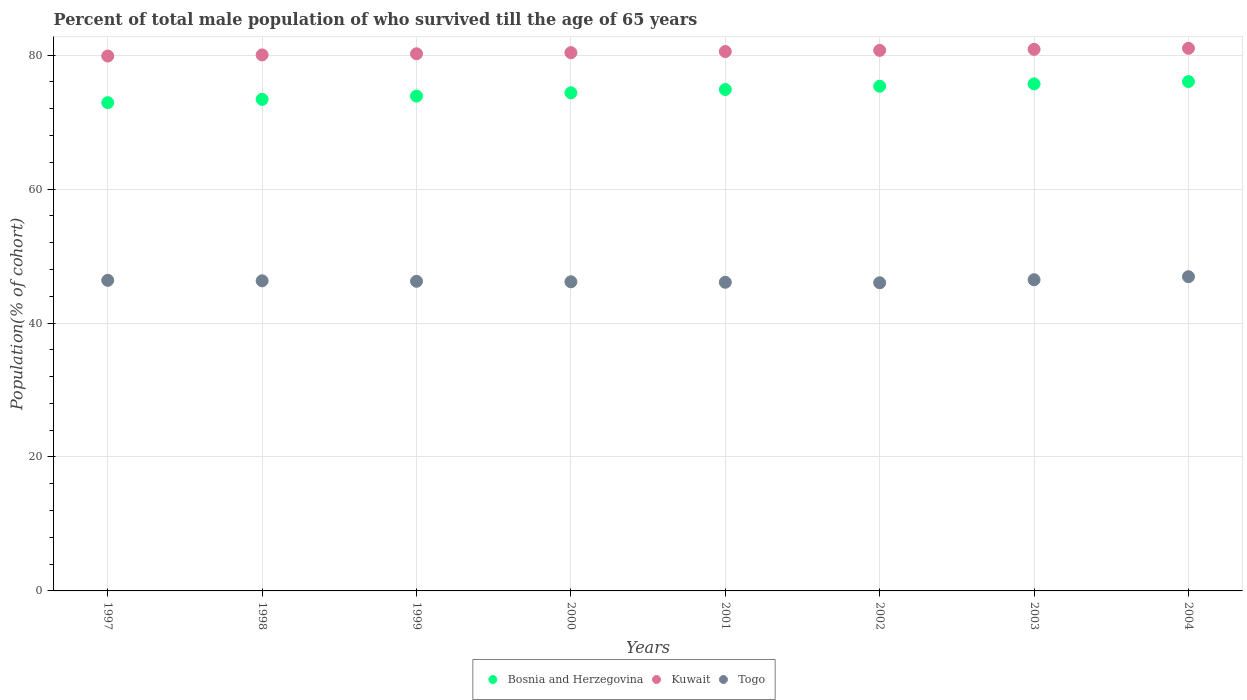How many different coloured dotlines are there?
Offer a very short reply. 3. What is the percentage of total male population who survived till the age of 65 years in Togo in 1998?
Your response must be concise. 46.31. Across all years, what is the maximum percentage of total male population who survived till the age of 65 years in Togo?
Make the answer very short. 46.92. Across all years, what is the minimum percentage of total male population who survived till the age of 65 years in Bosnia and Herzegovina?
Make the answer very short. 72.91. In which year was the percentage of total male population who survived till the age of 65 years in Kuwait minimum?
Your answer should be compact. 1997. What is the total percentage of total male population who survived till the age of 65 years in Bosnia and Herzegovina in the graph?
Provide a succinct answer. 596.59. What is the difference between the percentage of total male population who survived till the age of 65 years in Kuwait in 2002 and that in 2003?
Give a very brief answer. -0.16. What is the difference between the percentage of total male population who survived till the age of 65 years in Bosnia and Herzegovina in 2004 and the percentage of total male population who survived till the age of 65 years in Kuwait in 2003?
Your answer should be very brief. -4.81. What is the average percentage of total male population who survived till the age of 65 years in Togo per year?
Your answer should be compact. 46.32. In the year 2002, what is the difference between the percentage of total male population who survived till the age of 65 years in Bosnia and Herzegovina and percentage of total male population who survived till the age of 65 years in Togo?
Give a very brief answer. 29.35. In how many years, is the percentage of total male population who survived till the age of 65 years in Togo greater than 48 %?
Provide a short and direct response. 0. What is the ratio of the percentage of total male population who survived till the age of 65 years in Togo in 1998 to that in 2003?
Provide a short and direct response. 1. What is the difference between the highest and the second highest percentage of total male population who survived till the age of 65 years in Togo?
Keep it short and to the point. 0.45. What is the difference between the highest and the lowest percentage of total male population who survived till the age of 65 years in Bosnia and Herzegovina?
Your response must be concise. 3.15. In how many years, is the percentage of total male population who survived till the age of 65 years in Togo greater than the average percentage of total male population who survived till the age of 65 years in Togo taken over all years?
Keep it short and to the point. 3. Is it the case that in every year, the sum of the percentage of total male population who survived till the age of 65 years in Togo and percentage of total male population who survived till the age of 65 years in Bosnia and Herzegovina  is greater than the percentage of total male population who survived till the age of 65 years in Kuwait?
Offer a terse response. Yes. Is the percentage of total male population who survived till the age of 65 years in Kuwait strictly less than the percentage of total male population who survived till the age of 65 years in Bosnia and Herzegovina over the years?
Your answer should be compact. No. What is the difference between two consecutive major ticks on the Y-axis?
Provide a short and direct response. 20. Are the values on the major ticks of Y-axis written in scientific E-notation?
Provide a short and direct response. No. Does the graph contain grids?
Give a very brief answer. Yes. How are the legend labels stacked?
Provide a succinct answer. Horizontal. What is the title of the graph?
Your answer should be compact. Percent of total male population of who survived till the age of 65 years. Does "Czech Republic" appear as one of the legend labels in the graph?
Your response must be concise. No. What is the label or title of the Y-axis?
Your answer should be very brief. Population(% of cohort). What is the Population(% of cohort) in Bosnia and Herzegovina in 1997?
Your response must be concise. 72.91. What is the Population(% of cohort) in Kuwait in 1997?
Offer a terse response. 79.87. What is the Population(% of cohort) in Togo in 1997?
Your answer should be very brief. 46.38. What is the Population(% of cohort) in Bosnia and Herzegovina in 1998?
Ensure brevity in your answer.  73.4. What is the Population(% of cohort) in Kuwait in 1998?
Ensure brevity in your answer.  80.04. What is the Population(% of cohort) in Togo in 1998?
Ensure brevity in your answer.  46.31. What is the Population(% of cohort) in Bosnia and Herzegovina in 1999?
Provide a succinct answer. 73.89. What is the Population(% of cohort) of Kuwait in 1999?
Provide a succinct answer. 80.21. What is the Population(% of cohort) in Togo in 1999?
Make the answer very short. 46.23. What is the Population(% of cohort) of Bosnia and Herzegovina in 2000?
Your response must be concise. 74.38. What is the Population(% of cohort) of Kuwait in 2000?
Provide a succinct answer. 80.38. What is the Population(% of cohort) of Togo in 2000?
Provide a succinct answer. 46.16. What is the Population(% of cohort) in Bosnia and Herzegovina in 2001?
Ensure brevity in your answer.  74.87. What is the Population(% of cohort) in Kuwait in 2001?
Offer a terse response. 80.55. What is the Population(% of cohort) of Togo in 2001?
Your response must be concise. 46.09. What is the Population(% of cohort) of Bosnia and Herzegovina in 2002?
Your answer should be compact. 75.36. What is the Population(% of cohort) in Kuwait in 2002?
Provide a short and direct response. 80.71. What is the Population(% of cohort) of Togo in 2002?
Provide a succinct answer. 46.01. What is the Population(% of cohort) in Bosnia and Herzegovina in 2003?
Give a very brief answer. 75.71. What is the Population(% of cohort) of Kuwait in 2003?
Provide a short and direct response. 80.87. What is the Population(% of cohort) of Togo in 2003?
Offer a terse response. 46.47. What is the Population(% of cohort) in Bosnia and Herzegovina in 2004?
Ensure brevity in your answer.  76.06. What is the Population(% of cohort) of Kuwait in 2004?
Your response must be concise. 81.03. What is the Population(% of cohort) in Togo in 2004?
Offer a terse response. 46.92. Across all years, what is the maximum Population(% of cohort) in Bosnia and Herzegovina?
Your response must be concise. 76.06. Across all years, what is the maximum Population(% of cohort) of Kuwait?
Make the answer very short. 81.03. Across all years, what is the maximum Population(% of cohort) in Togo?
Provide a succinct answer. 46.92. Across all years, what is the minimum Population(% of cohort) of Bosnia and Herzegovina?
Your answer should be very brief. 72.91. Across all years, what is the minimum Population(% of cohort) of Kuwait?
Provide a succinct answer. 79.87. Across all years, what is the minimum Population(% of cohort) of Togo?
Your response must be concise. 46.01. What is the total Population(% of cohort) of Bosnia and Herzegovina in the graph?
Make the answer very short. 596.59. What is the total Population(% of cohort) of Kuwait in the graph?
Your response must be concise. 643.65. What is the total Population(% of cohort) in Togo in the graph?
Your answer should be very brief. 370.56. What is the difference between the Population(% of cohort) of Bosnia and Herzegovina in 1997 and that in 1998?
Your response must be concise. -0.49. What is the difference between the Population(% of cohort) of Kuwait in 1997 and that in 1998?
Give a very brief answer. -0.17. What is the difference between the Population(% of cohort) of Togo in 1997 and that in 1998?
Offer a terse response. 0.07. What is the difference between the Population(% of cohort) of Bosnia and Herzegovina in 1997 and that in 1999?
Provide a succinct answer. -0.98. What is the difference between the Population(% of cohort) in Kuwait in 1997 and that in 1999?
Ensure brevity in your answer.  -0.34. What is the difference between the Population(% of cohort) of Togo in 1997 and that in 1999?
Provide a succinct answer. 0.15. What is the difference between the Population(% of cohort) of Bosnia and Herzegovina in 1997 and that in 2000?
Offer a very short reply. -1.47. What is the difference between the Population(% of cohort) of Kuwait in 1997 and that in 2000?
Provide a succinct answer. -0.51. What is the difference between the Population(% of cohort) of Togo in 1997 and that in 2000?
Offer a very short reply. 0.22. What is the difference between the Population(% of cohort) of Bosnia and Herzegovina in 1997 and that in 2001?
Ensure brevity in your answer.  -1.96. What is the difference between the Population(% of cohort) of Kuwait in 1997 and that in 2001?
Give a very brief answer. -0.67. What is the difference between the Population(% of cohort) in Togo in 1997 and that in 2001?
Provide a succinct answer. 0.29. What is the difference between the Population(% of cohort) of Bosnia and Herzegovina in 1997 and that in 2002?
Your answer should be very brief. -2.45. What is the difference between the Population(% of cohort) of Kuwait in 1997 and that in 2002?
Your answer should be compact. -0.84. What is the difference between the Population(% of cohort) of Togo in 1997 and that in 2002?
Provide a succinct answer. 0.36. What is the difference between the Population(% of cohort) of Bosnia and Herzegovina in 1997 and that in 2003?
Your answer should be compact. -2.8. What is the difference between the Population(% of cohort) of Kuwait in 1997 and that in 2003?
Make the answer very short. -1. What is the difference between the Population(% of cohort) in Togo in 1997 and that in 2003?
Provide a succinct answer. -0.09. What is the difference between the Population(% of cohort) of Bosnia and Herzegovina in 1997 and that in 2004?
Your answer should be very brief. -3.15. What is the difference between the Population(% of cohort) in Kuwait in 1997 and that in 2004?
Ensure brevity in your answer.  -1.15. What is the difference between the Population(% of cohort) in Togo in 1997 and that in 2004?
Your answer should be compact. -0.54. What is the difference between the Population(% of cohort) in Bosnia and Herzegovina in 1998 and that in 1999?
Provide a succinct answer. -0.49. What is the difference between the Population(% of cohort) of Kuwait in 1998 and that in 1999?
Provide a short and direct response. -0.17. What is the difference between the Population(% of cohort) of Togo in 1998 and that in 1999?
Your answer should be compact. 0.07. What is the difference between the Population(% of cohort) in Bosnia and Herzegovina in 1998 and that in 2000?
Provide a succinct answer. -0.98. What is the difference between the Population(% of cohort) of Kuwait in 1998 and that in 2000?
Your response must be concise. -0.34. What is the difference between the Population(% of cohort) in Togo in 1998 and that in 2000?
Offer a very short reply. 0.15. What is the difference between the Population(% of cohort) in Bosnia and Herzegovina in 1998 and that in 2001?
Make the answer very short. -1.47. What is the difference between the Population(% of cohort) in Kuwait in 1998 and that in 2001?
Provide a succinct answer. -0.51. What is the difference between the Population(% of cohort) of Togo in 1998 and that in 2001?
Keep it short and to the point. 0.22. What is the difference between the Population(% of cohort) of Bosnia and Herzegovina in 1998 and that in 2002?
Provide a short and direct response. -1.96. What is the difference between the Population(% of cohort) in Kuwait in 1998 and that in 2002?
Give a very brief answer. -0.67. What is the difference between the Population(% of cohort) in Togo in 1998 and that in 2002?
Give a very brief answer. 0.29. What is the difference between the Population(% of cohort) of Bosnia and Herzegovina in 1998 and that in 2003?
Provide a short and direct response. -2.31. What is the difference between the Population(% of cohort) of Kuwait in 1998 and that in 2003?
Ensure brevity in your answer.  -0.83. What is the difference between the Population(% of cohort) in Togo in 1998 and that in 2003?
Provide a succinct answer. -0.16. What is the difference between the Population(% of cohort) of Bosnia and Herzegovina in 1998 and that in 2004?
Offer a very short reply. -2.66. What is the difference between the Population(% of cohort) of Kuwait in 1998 and that in 2004?
Offer a very short reply. -0.99. What is the difference between the Population(% of cohort) in Togo in 1998 and that in 2004?
Offer a very short reply. -0.61. What is the difference between the Population(% of cohort) in Bosnia and Herzegovina in 1999 and that in 2000?
Your answer should be compact. -0.49. What is the difference between the Population(% of cohort) in Kuwait in 1999 and that in 2000?
Provide a succinct answer. -0.17. What is the difference between the Population(% of cohort) of Togo in 1999 and that in 2000?
Your answer should be very brief. 0.07. What is the difference between the Population(% of cohort) in Bosnia and Herzegovina in 1999 and that in 2001?
Your response must be concise. -0.98. What is the difference between the Population(% of cohort) of Kuwait in 1999 and that in 2001?
Give a very brief answer. -0.34. What is the difference between the Population(% of cohort) of Togo in 1999 and that in 2001?
Your answer should be very brief. 0.15. What is the difference between the Population(% of cohort) in Bosnia and Herzegovina in 1999 and that in 2002?
Make the answer very short. -1.47. What is the difference between the Population(% of cohort) of Kuwait in 1999 and that in 2002?
Your response must be concise. -0.51. What is the difference between the Population(% of cohort) of Togo in 1999 and that in 2002?
Provide a short and direct response. 0.22. What is the difference between the Population(% of cohort) of Bosnia and Herzegovina in 1999 and that in 2003?
Your response must be concise. -1.82. What is the difference between the Population(% of cohort) of Kuwait in 1999 and that in 2003?
Make the answer very short. -0.66. What is the difference between the Population(% of cohort) of Togo in 1999 and that in 2003?
Provide a short and direct response. -0.23. What is the difference between the Population(% of cohort) in Bosnia and Herzegovina in 1999 and that in 2004?
Provide a succinct answer. -2.17. What is the difference between the Population(% of cohort) of Kuwait in 1999 and that in 2004?
Your answer should be compact. -0.82. What is the difference between the Population(% of cohort) in Togo in 1999 and that in 2004?
Your answer should be compact. -0.68. What is the difference between the Population(% of cohort) of Bosnia and Herzegovina in 2000 and that in 2001?
Your answer should be very brief. -0.49. What is the difference between the Population(% of cohort) in Kuwait in 2000 and that in 2001?
Provide a short and direct response. -0.17. What is the difference between the Population(% of cohort) in Togo in 2000 and that in 2001?
Your response must be concise. 0.07. What is the difference between the Population(% of cohort) of Bosnia and Herzegovina in 2000 and that in 2002?
Your response must be concise. -0.98. What is the difference between the Population(% of cohort) of Kuwait in 2000 and that in 2002?
Your response must be concise. -0.34. What is the difference between the Population(% of cohort) in Togo in 2000 and that in 2002?
Offer a very short reply. 0.15. What is the difference between the Population(% of cohort) in Bosnia and Herzegovina in 2000 and that in 2003?
Offer a very short reply. -1.33. What is the difference between the Population(% of cohort) of Kuwait in 2000 and that in 2003?
Offer a terse response. -0.49. What is the difference between the Population(% of cohort) of Togo in 2000 and that in 2003?
Provide a succinct answer. -0.31. What is the difference between the Population(% of cohort) in Bosnia and Herzegovina in 2000 and that in 2004?
Make the answer very short. -1.68. What is the difference between the Population(% of cohort) in Kuwait in 2000 and that in 2004?
Make the answer very short. -0.65. What is the difference between the Population(% of cohort) in Togo in 2000 and that in 2004?
Your answer should be compact. -0.76. What is the difference between the Population(% of cohort) in Bosnia and Herzegovina in 2001 and that in 2002?
Give a very brief answer. -0.49. What is the difference between the Population(% of cohort) in Kuwait in 2001 and that in 2002?
Give a very brief answer. -0.17. What is the difference between the Population(% of cohort) in Togo in 2001 and that in 2002?
Offer a very short reply. 0.07. What is the difference between the Population(% of cohort) of Bosnia and Herzegovina in 2001 and that in 2003?
Provide a short and direct response. -0.84. What is the difference between the Population(% of cohort) of Kuwait in 2001 and that in 2003?
Keep it short and to the point. -0.32. What is the difference between the Population(% of cohort) of Togo in 2001 and that in 2003?
Provide a short and direct response. -0.38. What is the difference between the Population(% of cohort) of Bosnia and Herzegovina in 2001 and that in 2004?
Your response must be concise. -1.19. What is the difference between the Population(% of cohort) of Kuwait in 2001 and that in 2004?
Provide a succinct answer. -0.48. What is the difference between the Population(% of cohort) of Togo in 2001 and that in 2004?
Keep it short and to the point. -0.83. What is the difference between the Population(% of cohort) in Bosnia and Herzegovina in 2002 and that in 2003?
Your response must be concise. -0.35. What is the difference between the Population(% of cohort) of Kuwait in 2002 and that in 2003?
Ensure brevity in your answer.  -0.16. What is the difference between the Population(% of cohort) of Togo in 2002 and that in 2003?
Your response must be concise. -0.45. What is the difference between the Population(% of cohort) in Bosnia and Herzegovina in 2002 and that in 2004?
Offer a terse response. -0.7. What is the difference between the Population(% of cohort) in Kuwait in 2002 and that in 2004?
Make the answer very short. -0.31. What is the difference between the Population(% of cohort) in Togo in 2002 and that in 2004?
Your answer should be very brief. -0.9. What is the difference between the Population(% of cohort) in Bosnia and Herzegovina in 2003 and that in 2004?
Ensure brevity in your answer.  -0.35. What is the difference between the Population(% of cohort) in Kuwait in 2003 and that in 2004?
Give a very brief answer. -0.16. What is the difference between the Population(% of cohort) in Togo in 2003 and that in 2004?
Your answer should be very brief. -0.45. What is the difference between the Population(% of cohort) of Bosnia and Herzegovina in 1997 and the Population(% of cohort) of Kuwait in 1998?
Your answer should be very brief. -7.13. What is the difference between the Population(% of cohort) in Bosnia and Herzegovina in 1997 and the Population(% of cohort) in Togo in 1998?
Offer a terse response. 26.6. What is the difference between the Population(% of cohort) in Kuwait in 1997 and the Population(% of cohort) in Togo in 1998?
Offer a terse response. 33.57. What is the difference between the Population(% of cohort) of Bosnia and Herzegovina in 1997 and the Population(% of cohort) of Kuwait in 1999?
Offer a very short reply. -7.3. What is the difference between the Population(% of cohort) in Bosnia and Herzegovina in 1997 and the Population(% of cohort) in Togo in 1999?
Ensure brevity in your answer.  26.68. What is the difference between the Population(% of cohort) of Kuwait in 1997 and the Population(% of cohort) of Togo in 1999?
Keep it short and to the point. 33.64. What is the difference between the Population(% of cohort) in Bosnia and Herzegovina in 1997 and the Population(% of cohort) in Kuwait in 2000?
Your response must be concise. -7.47. What is the difference between the Population(% of cohort) of Bosnia and Herzegovina in 1997 and the Population(% of cohort) of Togo in 2000?
Your response must be concise. 26.75. What is the difference between the Population(% of cohort) in Kuwait in 1997 and the Population(% of cohort) in Togo in 2000?
Keep it short and to the point. 33.71. What is the difference between the Population(% of cohort) in Bosnia and Herzegovina in 1997 and the Population(% of cohort) in Kuwait in 2001?
Keep it short and to the point. -7.64. What is the difference between the Population(% of cohort) in Bosnia and Herzegovina in 1997 and the Population(% of cohort) in Togo in 2001?
Keep it short and to the point. 26.82. What is the difference between the Population(% of cohort) of Kuwait in 1997 and the Population(% of cohort) of Togo in 2001?
Offer a terse response. 33.78. What is the difference between the Population(% of cohort) of Bosnia and Herzegovina in 1997 and the Population(% of cohort) of Kuwait in 2002?
Your response must be concise. -7.81. What is the difference between the Population(% of cohort) in Bosnia and Herzegovina in 1997 and the Population(% of cohort) in Togo in 2002?
Your answer should be very brief. 26.89. What is the difference between the Population(% of cohort) of Kuwait in 1997 and the Population(% of cohort) of Togo in 2002?
Make the answer very short. 33.86. What is the difference between the Population(% of cohort) of Bosnia and Herzegovina in 1997 and the Population(% of cohort) of Kuwait in 2003?
Your answer should be compact. -7.96. What is the difference between the Population(% of cohort) in Bosnia and Herzegovina in 1997 and the Population(% of cohort) in Togo in 2003?
Your answer should be very brief. 26.44. What is the difference between the Population(% of cohort) of Kuwait in 1997 and the Population(% of cohort) of Togo in 2003?
Offer a very short reply. 33.41. What is the difference between the Population(% of cohort) of Bosnia and Herzegovina in 1997 and the Population(% of cohort) of Kuwait in 2004?
Keep it short and to the point. -8.12. What is the difference between the Population(% of cohort) in Bosnia and Herzegovina in 1997 and the Population(% of cohort) in Togo in 2004?
Your response must be concise. 25.99. What is the difference between the Population(% of cohort) in Kuwait in 1997 and the Population(% of cohort) in Togo in 2004?
Ensure brevity in your answer.  32.95. What is the difference between the Population(% of cohort) of Bosnia and Herzegovina in 1998 and the Population(% of cohort) of Kuwait in 1999?
Keep it short and to the point. -6.81. What is the difference between the Population(% of cohort) in Bosnia and Herzegovina in 1998 and the Population(% of cohort) in Togo in 1999?
Give a very brief answer. 27.17. What is the difference between the Population(% of cohort) of Kuwait in 1998 and the Population(% of cohort) of Togo in 1999?
Keep it short and to the point. 33.81. What is the difference between the Population(% of cohort) in Bosnia and Herzegovina in 1998 and the Population(% of cohort) in Kuwait in 2000?
Give a very brief answer. -6.98. What is the difference between the Population(% of cohort) of Bosnia and Herzegovina in 1998 and the Population(% of cohort) of Togo in 2000?
Ensure brevity in your answer.  27.24. What is the difference between the Population(% of cohort) of Kuwait in 1998 and the Population(% of cohort) of Togo in 2000?
Offer a terse response. 33.88. What is the difference between the Population(% of cohort) of Bosnia and Herzegovina in 1998 and the Population(% of cohort) of Kuwait in 2001?
Your answer should be compact. -7.15. What is the difference between the Population(% of cohort) of Bosnia and Herzegovina in 1998 and the Population(% of cohort) of Togo in 2001?
Offer a very short reply. 27.31. What is the difference between the Population(% of cohort) of Kuwait in 1998 and the Population(% of cohort) of Togo in 2001?
Keep it short and to the point. 33.95. What is the difference between the Population(% of cohort) in Bosnia and Herzegovina in 1998 and the Population(% of cohort) in Kuwait in 2002?
Make the answer very short. -7.31. What is the difference between the Population(% of cohort) of Bosnia and Herzegovina in 1998 and the Population(% of cohort) of Togo in 2002?
Offer a terse response. 27.38. What is the difference between the Population(% of cohort) of Kuwait in 1998 and the Population(% of cohort) of Togo in 2002?
Your response must be concise. 34.02. What is the difference between the Population(% of cohort) of Bosnia and Herzegovina in 1998 and the Population(% of cohort) of Kuwait in 2003?
Your answer should be compact. -7.47. What is the difference between the Population(% of cohort) of Bosnia and Herzegovina in 1998 and the Population(% of cohort) of Togo in 2003?
Make the answer very short. 26.93. What is the difference between the Population(% of cohort) in Kuwait in 1998 and the Population(% of cohort) in Togo in 2003?
Your response must be concise. 33.57. What is the difference between the Population(% of cohort) in Bosnia and Herzegovina in 1998 and the Population(% of cohort) in Kuwait in 2004?
Give a very brief answer. -7.63. What is the difference between the Population(% of cohort) in Bosnia and Herzegovina in 1998 and the Population(% of cohort) in Togo in 2004?
Keep it short and to the point. 26.48. What is the difference between the Population(% of cohort) of Kuwait in 1998 and the Population(% of cohort) of Togo in 2004?
Offer a terse response. 33.12. What is the difference between the Population(% of cohort) of Bosnia and Herzegovina in 1999 and the Population(% of cohort) of Kuwait in 2000?
Keep it short and to the point. -6.49. What is the difference between the Population(% of cohort) in Bosnia and Herzegovina in 1999 and the Population(% of cohort) in Togo in 2000?
Give a very brief answer. 27.73. What is the difference between the Population(% of cohort) in Kuwait in 1999 and the Population(% of cohort) in Togo in 2000?
Offer a very short reply. 34.05. What is the difference between the Population(% of cohort) of Bosnia and Herzegovina in 1999 and the Population(% of cohort) of Kuwait in 2001?
Offer a terse response. -6.66. What is the difference between the Population(% of cohort) of Bosnia and Herzegovina in 1999 and the Population(% of cohort) of Togo in 2001?
Provide a short and direct response. 27.8. What is the difference between the Population(% of cohort) in Kuwait in 1999 and the Population(% of cohort) in Togo in 2001?
Provide a succinct answer. 34.12. What is the difference between the Population(% of cohort) in Bosnia and Herzegovina in 1999 and the Population(% of cohort) in Kuwait in 2002?
Keep it short and to the point. -6.82. What is the difference between the Population(% of cohort) in Bosnia and Herzegovina in 1999 and the Population(% of cohort) in Togo in 2002?
Your response must be concise. 27.88. What is the difference between the Population(% of cohort) of Kuwait in 1999 and the Population(% of cohort) of Togo in 2002?
Provide a succinct answer. 34.19. What is the difference between the Population(% of cohort) of Bosnia and Herzegovina in 1999 and the Population(% of cohort) of Kuwait in 2003?
Keep it short and to the point. -6.98. What is the difference between the Population(% of cohort) in Bosnia and Herzegovina in 1999 and the Population(% of cohort) in Togo in 2003?
Give a very brief answer. 27.43. What is the difference between the Population(% of cohort) of Kuwait in 1999 and the Population(% of cohort) of Togo in 2003?
Your answer should be very brief. 33.74. What is the difference between the Population(% of cohort) of Bosnia and Herzegovina in 1999 and the Population(% of cohort) of Kuwait in 2004?
Provide a short and direct response. -7.14. What is the difference between the Population(% of cohort) of Bosnia and Herzegovina in 1999 and the Population(% of cohort) of Togo in 2004?
Make the answer very short. 26.97. What is the difference between the Population(% of cohort) in Kuwait in 1999 and the Population(% of cohort) in Togo in 2004?
Offer a terse response. 33.29. What is the difference between the Population(% of cohort) in Bosnia and Herzegovina in 2000 and the Population(% of cohort) in Kuwait in 2001?
Your answer should be very brief. -6.16. What is the difference between the Population(% of cohort) of Bosnia and Herzegovina in 2000 and the Population(% of cohort) of Togo in 2001?
Provide a succinct answer. 28.29. What is the difference between the Population(% of cohort) of Kuwait in 2000 and the Population(% of cohort) of Togo in 2001?
Your answer should be compact. 34.29. What is the difference between the Population(% of cohort) in Bosnia and Herzegovina in 2000 and the Population(% of cohort) in Kuwait in 2002?
Keep it short and to the point. -6.33. What is the difference between the Population(% of cohort) in Bosnia and Herzegovina in 2000 and the Population(% of cohort) in Togo in 2002?
Ensure brevity in your answer.  28.37. What is the difference between the Population(% of cohort) in Kuwait in 2000 and the Population(% of cohort) in Togo in 2002?
Your response must be concise. 34.36. What is the difference between the Population(% of cohort) in Bosnia and Herzegovina in 2000 and the Population(% of cohort) in Kuwait in 2003?
Offer a terse response. -6.49. What is the difference between the Population(% of cohort) of Bosnia and Herzegovina in 2000 and the Population(% of cohort) of Togo in 2003?
Provide a short and direct response. 27.92. What is the difference between the Population(% of cohort) of Kuwait in 2000 and the Population(% of cohort) of Togo in 2003?
Your answer should be compact. 33.91. What is the difference between the Population(% of cohort) of Bosnia and Herzegovina in 2000 and the Population(% of cohort) of Kuwait in 2004?
Give a very brief answer. -6.64. What is the difference between the Population(% of cohort) of Bosnia and Herzegovina in 2000 and the Population(% of cohort) of Togo in 2004?
Offer a very short reply. 27.47. What is the difference between the Population(% of cohort) of Kuwait in 2000 and the Population(% of cohort) of Togo in 2004?
Keep it short and to the point. 33.46. What is the difference between the Population(% of cohort) in Bosnia and Herzegovina in 2001 and the Population(% of cohort) in Kuwait in 2002?
Your response must be concise. -5.84. What is the difference between the Population(% of cohort) of Bosnia and Herzegovina in 2001 and the Population(% of cohort) of Togo in 2002?
Your answer should be very brief. 28.86. What is the difference between the Population(% of cohort) in Kuwait in 2001 and the Population(% of cohort) in Togo in 2002?
Your answer should be compact. 34.53. What is the difference between the Population(% of cohort) in Bosnia and Herzegovina in 2001 and the Population(% of cohort) in Kuwait in 2003?
Ensure brevity in your answer.  -6. What is the difference between the Population(% of cohort) in Bosnia and Herzegovina in 2001 and the Population(% of cohort) in Togo in 2003?
Ensure brevity in your answer.  28.41. What is the difference between the Population(% of cohort) of Kuwait in 2001 and the Population(% of cohort) of Togo in 2003?
Provide a short and direct response. 34.08. What is the difference between the Population(% of cohort) of Bosnia and Herzegovina in 2001 and the Population(% of cohort) of Kuwait in 2004?
Provide a short and direct response. -6.15. What is the difference between the Population(% of cohort) of Bosnia and Herzegovina in 2001 and the Population(% of cohort) of Togo in 2004?
Provide a succinct answer. 27.96. What is the difference between the Population(% of cohort) of Kuwait in 2001 and the Population(% of cohort) of Togo in 2004?
Offer a terse response. 33.63. What is the difference between the Population(% of cohort) of Bosnia and Herzegovina in 2002 and the Population(% of cohort) of Kuwait in 2003?
Ensure brevity in your answer.  -5.51. What is the difference between the Population(% of cohort) of Bosnia and Herzegovina in 2002 and the Population(% of cohort) of Togo in 2003?
Offer a very short reply. 28.9. What is the difference between the Population(% of cohort) in Kuwait in 2002 and the Population(% of cohort) in Togo in 2003?
Provide a succinct answer. 34.25. What is the difference between the Population(% of cohort) of Bosnia and Herzegovina in 2002 and the Population(% of cohort) of Kuwait in 2004?
Provide a succinct answer. -5.66. What is the difference between the Population(% of cohort) of Bosnia and Herzegovina in 2002 and the Population(% of cohort) of Togo in 2004?
Offer a very short reply. 28.45. What is the difference between the Population(% of cohort) in Kuwait in 2002 and the Population(% of cohort) in Togo in 2004?
Make the answer very short. 33.8. What is the difference between the Population(% of cohort) in Bosnia and Herzegovina in 2003 and the Population(% of cohort) in Kuwait in 2004?
Offer a terse response. -5.31. What is the difference between the Population(% of cohort) of Bosnia and Herzegovina in 2003 and the Population(% of cohort) of Togo in 2004?
Provide a succinct answer. 28.79. What is the difference between the Population(% of cohort) in Kuwait in 2003 and the Population(% of cohort) in Togo in 2004?
Ensure brevity in your answer.  33.95. What is the average Population(% of cohort) in Bosnia and Herzegovina per year?
Keep it short and to the point. 74.57. What is the average Population(% of cohort) in Kuwait per year?
Your response must be concise. 80.46. What is the average Population(% of cohort) of Togo per year?
Keep it short and to the point. 46.32. In the year 1997, what is the difference between the Population(% of cohort) of Bosnia and Herzegovina and Population(% of cohort) of Kuwait?
Ensure brevity in your answer.  -6.96. In the year 1997, what is the difference between the Population(% of cohort) of Bosnia and Herzegovina and Population(% of cohort) of Togo?
Provide a succinct answer. 26.53. In the year 1997, what is the difference between the Population(% of cohort) of Kuwait and Population(% of cohort) of Togo?
Keep it short and to the point. 33.49. In the year 1998, what is the difference between the Population(% of cohort) of Bosnia and Herzegovina and Population(% of cohort) of Kuwait?
Your response must be concise. -6.64. In the year 1998, what is the difference between the Population(% of cohort) in Bosnia and Herzegovina and Population(% of cohort) in Togo?
Offer a terse response. 27.09. In the year 1998, what is the difference between the Population(% of cohort) of Kuwait and Population(% of cohort) of Togo?
Offer a very short reply. 33.73. In the year 1999, what is the difference between the Population(% of cohort) in Bosnia and Herzegovina and Population(% of cohort) in Kuwait?
Offer a terse response. -6.32. In the year 1999, what is the difference between the Population(% of cohort) of Bosnia and Herzegovina and Population(% of cohort) of Togo?
Provide a short and direct response. 27.66. In the year 1999, what is the difference between the Population(% of cohort) in Kuwait and Population(% of cohort) in Togo?
Ensure brevity in your answer.  33.98. In the year 2000, what is the difference between the Population(% of cohort) of Bosnia and Herzegovina and Population(% of cohort) of Kuwait?
Provide a succinct answer. -6. In the year 2000, what is the difference between the Population(% of cohort) of Bosnia and Herzegovina and Population(% of cohort) of Togo?
Your answer should be compact. 28.22. In the year 2000, what is the difference between the Population(% of cohort) of Kuwait and Population(% of cohort) of Togo?
Ensure brevity in your answer.  34.22. In the year 2001, what is the difference between the Population(% of cohort) of Bosnia and Herzegovina and Population(% of cohort) of Kuwait?
Give a very brief answer. -5.67. In the year 2001, what is the difference between the Population(% of cohort) in Bosnia and Herzegovina and Population(% of cohort) in Togo?
Your answer should be compact. 28.78. In the year 2001, what is the difference between the Population(% of cohort) of Kuwait and Population(% of cohort) of Togo?
Keep it short and to the point. 34.46. In the year 2002, what is the difference between the Population(% of cohort) of Bosnia and Herzegovina and Population(% of cohort) of Kuwait?
Offer a terse response. -5.35. In the year 2002, what is the difference between the Population(% of cohort) in Bosnia and Herzegovina and Population(% of cohort) in Togo?
Make the answer very short. 29.35. In the year 2002, what is the difference between the Population(% of cohort) in Kuwait and Population(% of cohort) in Togo?
Offer a very short reply. 34.7. In the year 2003, what is the difference between the Population(% of cohort) of Bosnia and Herzegovina and Population(% of cohort) of Kuwait?
Offer a very short reply. -5.16. In the year 2003, what is the difference between the Population(% of cohort) of Bosnia and Herzegovina and Population(% of cohort) of Togo?
Offer a very short reply. 29.25. In the year 2003, what is the difference between the Population(% of cohort) of Kuwait and Population(% of cohort) of Togo?
Provide a short and direct response. 34.4. In the year 2004, what is the difference between the Population(% of cohort) of Bosnia and Herzegovina and Population(% of cohort) of Kuwait?
Give a very brief answer. -4.97. In the year 2004, what is the difference between the Population(% of cohort) in Bosnia and Herzegovina and Population(% of cohort) in Togo?
Keep it short and to the point. 29.14. In the year 2004, what is the difference between the Population(% of cohort) in Kuwait and Population(% of cohort) in Togo?
Give a very brief answer. 34.11. What is the ratio of the Population(% of cohort) of Bosnia and Herzegovina in 1997 to that in 1998?
Your response must be concise. 0.99. What is the ratio of the Population(% of cohort) in Togo in 1997 to that in 1998?
Make the answer very short. 1. What is the ratio of the Population(% of cohort) of Bosnia and Herzegovina in 1997 to that in 1999?
Ensure brevity in your answer.  0.99. What is the ratio of the Population(% of cohort) in Togo in 1997 to that in 1999?
Offer a very short reply. 1. What is the ratio of the Population(% of cohort) in Bosnia and Herzegovina in 1997 to that in 2000?
Ensure brevity in your answer.  0.98. What is the ratio of the Population(% of cohort) of Kuwait in 1997 to that in 2000?
Offer a very short reply. 0.99. What is the ratio of the Population(% of cohort) of Togo in 1997 to that in 2000?
Keep it short and to the point. 1. What is the ratio of the Population(% of cohort) in Bosnia and Herzegovina in 1997 to that in 2001?
Make the answer very short. 0.97. What is the ratio of the Population(% of cohort) in Kuwait in 1997 to that in 2001?
Offer a terse response. 0.99. What is the ratio of the Population(% of cohort) in Togo in 1997 to that in 2001?
Your answer should be compact. 1.01. What is the ratio of the Population(% of cohort) of Bosnia and Herzegovina in 1997 to that in 2002?
Keep it short and to the point. 0.97. What is the ratio of the Population(% of cohort) of Kuwait in 1997 to that in 2002?
Ensure brevity in your answer.  0.99. What is the ratio of the Population(% of cohort) in Togo in 1997 to that in 2002?
Ensure brevity in your answer.  1.01. What is the ratio of the Population(% of cohort) of Kuwait in 1997 to that in 2003?
Ensure brevity in your answer.  0.99. What is the ratio of the Population(% of cohort) in Bosnia and Herzegovina in 1997 to that in 2004?
Offer a terse response. 0.96. What is the ratio of the Population(% of cohort) in Kuwait in 1997 to that in 2004?
Your answer should be compact. 0.99. What is the ratio of the Population(% of cohort) in Togo in 1997 to that in 2004?
Offer a terse response. 0.99. What is the ratio of the Population(% of cohort) in Kuwait in 1998 to that in 2000?
Your answer should be compact. 1. What is the ratio of the Population(% of cohort) in Togo in 1998 to that in 2000?
Offer a terse response. 1. What is the ratio of the Population(% of cohort) in Bosnia and Herzegovina in 1998 to that in 2001?
Keep it short and to the point. 0.98. What is the ratio of the Population(% of cohort) in Bosnia and Herzegovina in 1998 to that in 2002?
Provide a short and direct response. 0.97. What is the ratio of the Population(% of cohort) in Kuwait in 1998 to that in 2002?
Keep it short and to the point. 0.99. What is the ratio of the Population(% of cohort) in Bosnia and Herzegovina in 1998 to that in 2003?
Your response must be concise. 0.97. What is the ratio of the Population(% of cohort) of Kuwait in 1998 to that in 2003?
Offer a terse response. 0.99. What is the ratio of the Population(% of cohort) of Togo in 1998 to that in 2003?
Keep it short and to the point. 1. What is the ratio of the Population(% of cohort) of Bosnia and Herzegovina in 1998 to that in 2004?
Offer a terse response. 0.96. What is the ratio of the Population(% of cohort) in Bosnia and Herzegovina in 1999 to that in 2001?
Ensure brevity in your answer.  0.99. What is the ratio of the Population(% of cohort) of Kuwait in 1999 to that in 2001?
Keep it short and to the point. 1. What is the ratio of the Population(% of cohort) of Bosnia and Herzegovina in 1999 to that in 2002?
Keep it short and to the point. 0.98. What is the ratio of the Population(% of cohort) of Togo in 1999 to that in 2002?
Offer a very short reply. 1. What is the ratio of the Population(% of cohort) in Kuwait in 1999 to that in 2003?
Offer a very short reply. 0.99. What is the ratio of the Population(% of cohort) of Bosnia and Herzegovina in 1999 to that in 2004?
Make the answer very short. 0.97. What is the ratio of the Population(% of cohort) in Kuwait in 1999 to that in 2004?
Provide a short and direct response. 0.99. What is the ratio of the Population(% of cohort) of Togo in 1999 to that in 2004?
Keep it short and to the point. 0.99. What is the ratio of the Population(% of cohort) in Bosnia and Herzegovina in 2000 to that in 2001?
Your response must be concise. 0.99. What is the ratio of the Population(% of cohort) in Togo in 2000 to that in 2001?
Give a very brief answer. 1. What is the ratio of the Population(% of cohort) of Kuwait in 2000 to that in 2002?
Your response must be concise. 1. What is the ratio of the Population(% of cohort) in Bosnia and Herzegovina in 2000 to that in 2003?
Your answer should be very brief. 0.98. What is the ratio of the Population(% of cohort) of Bosnia and Herzegovina in 2000 to that in 2004?
Keep it short and to the point. 0.98. What is the ratio of the Population(% of cohort) of Togo in 2000 to that in 2004?
Keep it short and to the point. 0.98. What is the ratio of the Population(% of cohort) of Bosnia and Herzegovina in 2001 to that in 2002?
Your answer should be compact. 0.99. What is the ratio of the Population(% of cohort) of Bosnia and Herzegovina in 2001 to that in 2003?
Ensure brevity in your answer.  0.99. What is the ratio of the Population(% of cohort) in Kuwait in 2001 to that in 2003?
Provide a short and direct response. 1. What is the ratio of the Population(% of cohort) in Togo in 2001 to that in 2003?
Give a very brief answer. 0.99. What is the ratio of the Population(% of cohort) of Bosnia and Herzegovina in 2001 to that in 2004?
Your answer should be very brief. 0.98. What is the ratio of the Population(% of cohort) of Togo in 2001 to that in 2004?
Offer a very short reply. 0.98. What is the ratio of the Population(% of cohort) of Bosnia and Herzegovina in 2002 to that in 2003?
Ensure brevity in your answer.  1. What is the ratio of the Population(% of cohort) of Togo in 2002 to that in 2003?
Offer a terse response. 0.99. What is the ratio of the Population(% of cohort) in Bosnia and Herzegovina in 2002 to that in 2004?
Your response must be concise. 0.99. What is the ratio of the Population(% of cohort) of Togo in 2002 to that in 2004?
Provide a short and direct response. 0.98. What is the ratio of the Population(% of cohort) in Bosnia and Herzegovina in 2003 to that in 2004?
Your answer should be compact. 1. What is the ratio of the Population(% of cohort) of Togo in 2003 to that in 2004?
Offer a very short reply. 0.99. What is the difference between the highest and the second highest Population(% of cohort) in Bosnia and Herzegovina?
Make the answer very short. 0.35. What is the difference between the highest and the second highest Population(% of cohort) of Kuwait?
Your response must be concise. 0.16. What is the difference between the highest and the second highest Population(% of cohort) of Togo?
Your answer should be very brief. 0.45. What is the difference between the highest and the lowest Population(% of cohort) in Bosnia and Herzegovina?
Offer a very short reply. 3.15. What is the difference between the highest and the lowest Population(% of cohort) in Kuwait?
Ensure brevity in your answer.  1.15. What is the difference between the highest and the lowest Population(% of cohort) in Togo?
Make the answer very short. 0.9. 